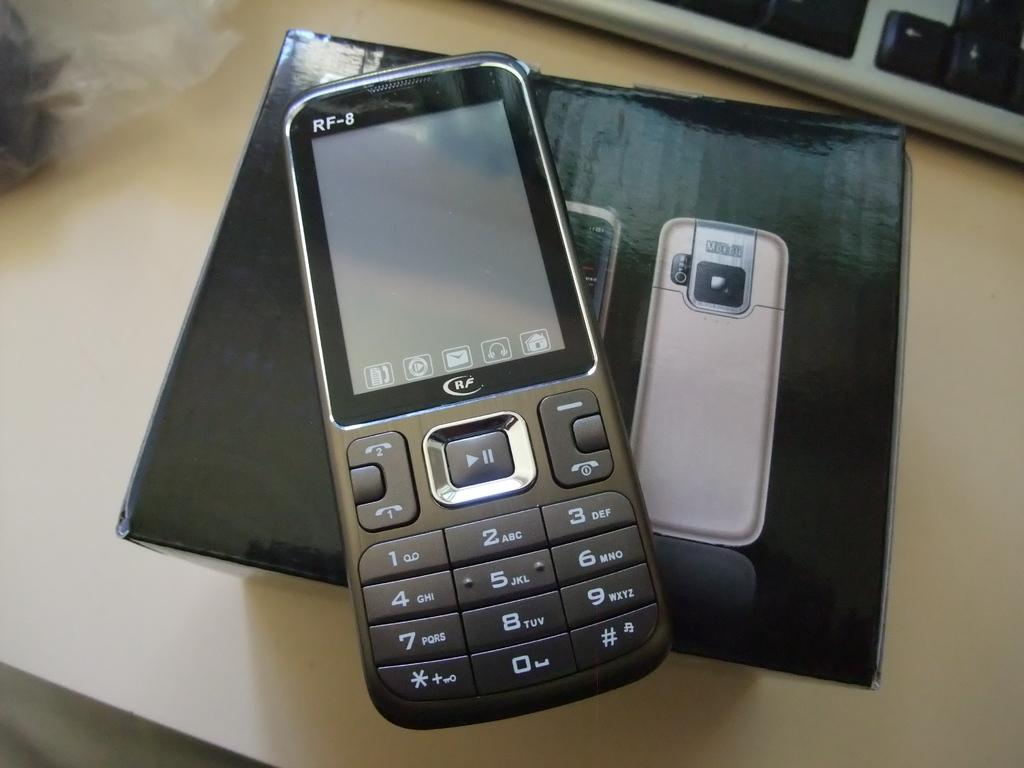<image>
Write a terse but informative summary of the picture. a phone that had RF written on it 